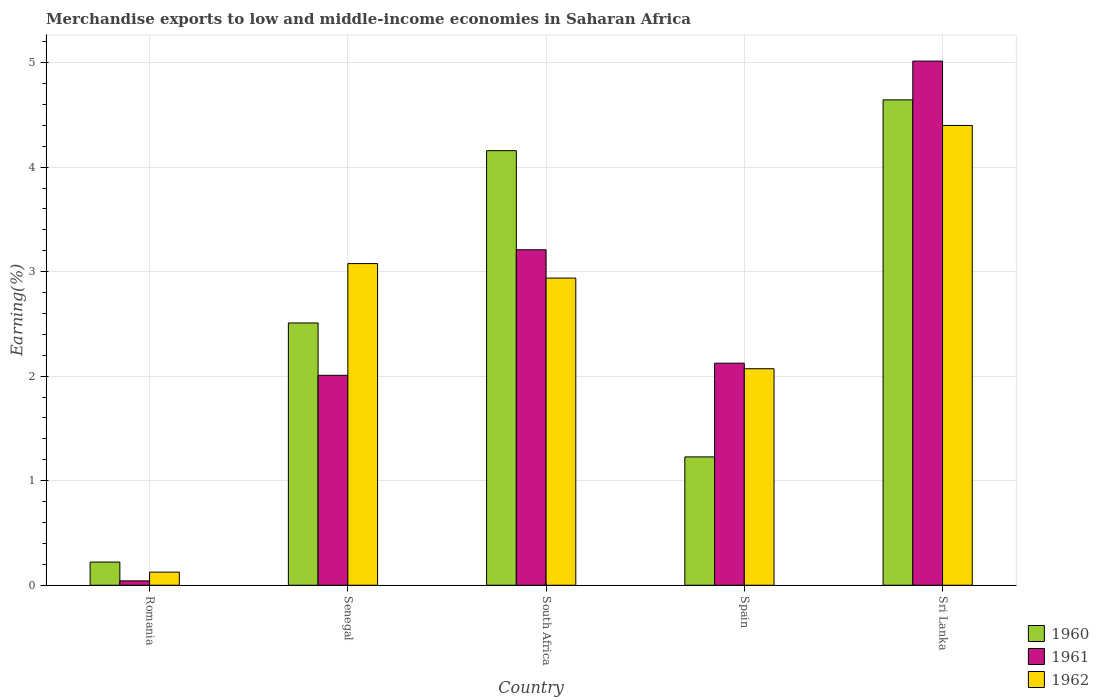How many different coloured bars are there?
Offer a terse response. 3. How many groups of bars are there?
Offer a very short reply. 5. Are the number of bars per tick equal to the number of legend labels?
Ensure brevity in your answer.  Yes. How many bars are there on the 1st tick from the left?
Ensure brevity in your answer.  3. What is the label of the 2nd group of bars from the left?
Your answer should be very brief. Senegal. What is the percentage of amount earned from merchandise exports in 1961 in Sri Lanka?
Offer a very short reply. 5.01. Across all countries, what is the maximum percentage of amount earned from merchandise exports in 1962?
Keep it short and to the point. 4.4. Across all countries, what is the minimum percentage of amount earned from merchandise exports in 1960?
Provide a succinct answer. 0.22. In which country was the percentage of amount earned from merchandise exports in 1960 maximum?
Your answer should be compact. Sri Lanka. In which country was the percentage of amount earned from merchandise exports in 1962 minimum?
Your response must be concise. Romania. What is the total percentage of amount earned from merchandise exports in 1962 in the graph?
Provide a succinct answer. 12.61. What is the difference between the percentage of amount earned from merchandise exports in 1960 in Spain and that in Sri Lanka?
Ensure brevity in your answer.  -3.42. What is the difference between the percentage of amount earned from merchandise exports in 1962 in Sri Lanka and the percentage of amount earned from merchandise exports in 1961 in South Africa?
Your answer should be very brief. 1.19. What is the average percentage of amount earned from merchandise exports in 1962 per country?
Offer a terse response. 2.52. What is the difference between the percentage of amount earned from merchandise exports of/in 1962 and percentage of amount earned from merchandise exports of/in 1960 in South Africa?
Your answer should be compact. -1.22. In how many countries, is the percentage of amount earned from merchandise exports in 1961 greater than 1 %?
Make the answer very short. 4. What is the ratio of the percentage of amount earned from merchandise exports in 1962 in Spain to that in Sri Lanka?
Provide a succinct answer. 0.47. Is the percentage of amount earned from merchandise exports in 1961 in Romania less than that in Spain?
Provide a succinct answer. Yes. Is the difference between the percentage of amount earned from merchandise exports in 1962 in Romania and Senegal greater than the difference between the percentage of amount earned from merchandise exports in 1960 in Romania and Senegal?
Your answer should be very brief. No. What is the difference between the highest and the second highest percentage of amount earned from merchandise exports in 1961?
Your response must be concise. -1.09. What is the difference between the highest and the lowest percentage of amount earned from merchandise exports in 1961?
Give a very brief answer. 4.97. Is the sum of the percentage of amount earned from merchandise exports in 1960 in Romania and South Africa greater than the maximum percentage of amount earned from merchandise exports in 1961 across all countries?
Provide a succinct answer. No. How many bars are there?
Give a very brief answer. 15. Are all the bars in the graph horizontal?
Your answer should be very brief. No. How many countries are there in the graph?
Give a very brief answer. 5. What is the difference between two consecutive major ticks on the Y-axis?
Offer a terse response. 1. Are the values on the major ticks of Y-axis written in scientific E-notation?
Ensure brevity in your answer.  No. Does the graph contain grids?
Provide a succinct answer. Yes. What is the title of the graph?
Your answer should be compact. Merchandise exports to low and middle-income economies in Saharan Africa. What is the label or title of the Y-axis?
Provide a short and direct response. Earning(%). What is the Earning(%) of 1960 in Romania?
Make the answer very short. 0.22. What is the Earning(%) of 1961 in Romania?
Your answer should be very brief. 0.04. What is the Earning(%) in 1962 in Romania?
Keep it short and to the point. 0.13. What is the Earning(%) in 1960 in Senegal?
Offer a very short reply. 2.51. What is the Earning(%) of 1961 in Senegal?
Keep it short and to the point. 2.01. What is the Earning(%) in 1962 in Senegal?
Offer a terse response. 3.08. What is the Earning(%) in 1960 in South Africa?
Offer a terse response. 4.16. What is the Earning(%) in 1961 in South Africa?
Your answer should be compact. 3.21. What is the Earning(%) in 1962 in South Africa?
Ensure brevity in your answer.  2.94. What is the Earning(%) of 1960 in Spain?
Give a very brief answer. 1.23. What is the Earning(%) in 1961 in Spain?
Provide a succinct answer. 2.12. What is the Earning(%) of 1962 in Spain?
Offer a very short reply. 2.07. What is the Earning(%) of 1960 in Sri Lanka?
Your answer should be very brief. 4.64. What is the Earning(%) in 1961 in Sri Lanka?
Offer a terse response. 5.01. What is the Earning(%) in 1962 in Sri Lanka?
Your answer should be compact. 4.4. Across all countries, what is the maximum Earning(%) of 1960?
Provide a short and direct response. 4.64. Across all countries, what is the maximum Earning(%) in 1961?
Provide a short and direct response. 5.01. Across all countries, what is the maximum Earning(%) of 1962?
Your answer should be compact. 4.4. Across all countries, what is the minimum Earning(%) in 1960?
Your response must be concise. 0.22. Across all countries, what is the minimum Earning(%) of 1961?
Give a very brief answer. 0.04. Across all countries, what is the minimum Earning(%) of 1962?
Your answer should be very brief. 0.13. What is the total Earning(%) of 1960 in the graph?
Ensure brevity in your answer.  12.76. What is the total Earning(%) in 1961 in the graph?
Offer a terse response. 12.4. What is the total Earning(%) of 1962 in the graph?
Offer a terse response. 12.61. What is the difference between the Earning(%) of 1960 in Romania and that in Senegal?
Your answer should be very brief. -2.29. What is the difference between the Earning(%) of 1961 in Romania and that in Senegal?
Keep it short and to the point. -1.97. What is the difference between the Earning(%) of 1962 in Romania and that in Senegal?
Offer a very short reply. -2.95. What is the difference between the Earning(%) in 1960 in Romania and that in South Africa?
Provide a short and direct response. -3.94. What is the difference between the Earning(%) of 1961 in Romania and that in South Africa?
Provide a short and direct response. -3.17. What is the difference between the Earning(%) of 1962 in Romania and that in South Africa?
Make the answer very short. -2.81. What is the difference between the Earning(%) of 1960 in Romania and that in Spain?
Your answer should be very brief. -1.01. What is the difference between the Earning(%) of 1961 in Romania and that in Spain?
Keep it short and to the point. -2.08. What is the difference between the Earning(%) of 1962 in Romania and that in Spain?
Provide a short and direct response. -1.95. What is the difference between the Earning(%) in 1960 in Romania and that in Sri Lanka?
Your answer should be compact. -4.42. What is the difference between the Earning(%) in 1961 in Romania and that in Sri Lanka?
Provide a short and direct response. -4.97. What is the difference between the Earning(%) in 1962 in Romania and that in Sri Lanka?
Your answer should be compact. -4.27. What is the difference between the Earning(%) of 1960 in Senegal and that in South Africa?
Give a very brief answer. -1.65. What is the difference between the Earning(%) of 1961 in Senegal and that in South Africa?
Offer a terse response. -1.2. What is the difference between the Earning(%) in 1962 in Senegal and that in South Africa?
Give a very brief answer. 0.14. What is the difference between the Earning(%) in 1960 in Senegal and that in Spain?
Provide a succinct answer. 1.28. What is the difference between the Earning(%) in 1961 in Senegal and that in Spain?
Your response must be concise. -0.12. What is the difference between the Earning(%) in 1960 in Senegal and that in Sri Lanka?
Your response must be concise. -2.13. What is the difference between the Earning(%) of 1961 in Senegal and that in Sri Lanka?
Your response must be concise. -3.01. What is the difference between the Earning(%) of 1962 in Senegal and that in Sri Lanka?
Give a very brief answer. -1.32. What is the difference between the Earning(%) of 1960 in South Africa and that in Spain?
Ensure brevity in your answer.  2.93. What is the difference between the Earning(%) of 1961 in South Africa and that in Spain?
Your answer should be compact. 1.09. What is the difference between the Earning(%) of 1962 in South Africa and that in Spain?
Your response must be concise. 0.87. What is the difference between the Earning(%) of 1960 in South Africa and that in Sri Lanka?
Ensure brevity in your answer.  -0.49. What is the difference between the Earning(%) in 1961 in South Africa and that in Sri Lanka?
Keep it short and to the point. -1.8. What is the difference between the Earning(%) of 1962 in South Africa and that in Sri Lanka?
Your answer should be very brief. -1.46. What is the difference between the Earning(%) of 1960 in Spain and that in Sri Lanka?
Provide a short and direct response. -3.42. What is the difference between the Earning(%) in 1961 in Spain and that in Sri Lanka?
Your answer should be very brief. -2.89. What is the difference between the Earning(%) of 1962 in Spain and that in Sri Lanka?
Keep it short and to the point. -2.33. What is the difference between the Earning(%) of 1960 in Romania and the Earning(%) of 1961 in Senegal?
Provide a short and direct response. -1.79. What is the difference between the Earning(%) in 1960 in Romania and the Earning(%) in 1962 in Senegal?
Ensure brevity in your answer.  -2.86. What is the difference between the Earning(%) in 1961 in Romania and the Earning(%) in 1962 in Senegal?
Your answer should be compact. -3.04. What is the difference between the Earning(%) in 1960 in Romania and the Earning(%) in 1961 in South Africa?
Offer a very short reply. -2.99. What is the difference between the Earning(%) of 1960 in Romania and the Earning(%) of 1962 in South Africa?
Provide a short and direct response. -2.72. What is the difference between the Earning(%) of 1961 in Romania and the Earning(%) of 1962 in South Africa?
Provide a short and direct response. -2.9. What is the difference between the Earning(%) in 1960 in Romania and the Earning(%) in 1961 in Spain?
Give a very brief answer. -1.9. What is the difference between the Earning(%) of 1960 in Romania and the Earning(%) of 1962 in Spain?
Offer a very short reply. -1.85. What is the difference between the Earning(%) in 1961 in Romania and the Earning(%) in 1962 in Spain?
Provide a succinct answer. -2.03. What is the difference between the Earning(%) in 1960 in Romania and the Earning(%) in 1961 in Sri Lanka?
Your answer should be very brief. -4.79. What is the difference between the Earning(%) in 1960 in Romania and the Earning(%) in 1962 in Sri Lanka?
Offer a very short reply. -4.18. What is the difference between the Earning(%) of 1961 in Romania and the Earning(%) of 1962 in Sri Lanka?
Your answer should be very brief. -4.36. What is the difference between the Earning(%) in 1960 in Senegal and the Earning(%) in 1961 in South Africa?
Ensure brevity in your answer.  -0.7. What is the difference between the Earning(%) in 1960 in Senegal and the Earning(%) in 1962 in South Africa?
Make the answer very short. -0.43. What is the difference between the Earning(%) of 1961 in Senegal and the Earning(%) of 1962 in South Africa?
Your answer should be compact. -0.93. What is the difference between the Earning(%) in 1960 in Senegal and the Earning(%) in 1961 in Spain?
Give a very brief answer. 0.38. What is the difference between the Earning(%) of 1960 in Senegal and the Earning(%) of 1962 in Spain?
Your answer should be compact. 0.44. What is the difference between the Earning(%) of 1961 in Senegal and the Earning(%) of 1962 in Spain?
Offer a terse response. -0.06. What is the difference between the Earning(%) of 1960 in Senegal and the Earning(%) of 1961 in Sri Lanka?
Ensure brevity in your answer.  -2.51. What is the difference between the Earning(%) of 1960 in Senegal and the Earning(%) of 1962 in Sri Lanka?
Your answer should be compact. -1.89. What is the difference between the Earning(%) of 1961 in Senegal and the Earning(%) of 1962 in Sri Lanka?
Give a very brief answer. -2.39. What is the difference between the Earning(%) of 1960 in South Africa and the Earning(%) of 1961 in Spain?
Give a very brief answer. 2.03. What is the difference between the Earning(%) of 1960 in South Africa and the Earning(%) of 1962 in Spain?
Your answer should be compact. 2.09. What is the difference between the Earning(%) of 1961 in South Africa and the Earning(%) of 1962 in Spain?
Your response must be concise. 1.14. What is the difference between the Earning(%) in 1960 in South Africa and the Earning(%) in 1961 in Sri Lanka?
Your response must be concise. -0.86. What is the difference between the Earning(%) in 1960 in South Africa and the Earning(%) in 1962 in Sri Lanka?
Provide a short and direct response. -0.24. What is the difference between the Earning(%) of 1961 in South Africa and the Earning(%) of 1962 in Sri Lanka?
Ensure brevity in your answer.  -1.19. What is the difference between the Earning(%) of 1960 in Spain and the Earning(%) of 1961 in Sri Lanka?
Offer a terse response. -3.79. What is the difference between the Earning(%) in 1960 in Spain and the Earning(%) in 1962 in Sri Lanka?
Ensure brevity in your answer.  -3.17. What is the difference between the Earning(%) in 1961 in Spain and the Earning(%) in 1962 in Sri Lanka?
Your answer should be compact. -2.27. What is the average Earning(%) of 1960 per country?
Your answer should be compact. 2.55. What is the average Earning(%) in 1961 per country?
Offer a very short reply. 2.48. What is the average Earning(%) in 1962 per country?
Make the answer very short. 2.52. What is the difference between the Earning(%) of 1960 and Earning(%) of 1961 in Romania?
Provide a succinct answer. 0.18. What is the difference between the Earning(%) of 1960 and Earning(%) of 1962 in Romania?
Offer a terse response. 0.1. What is the difference between the Earning(%) in 1961 and Earning(%) in 1962 in Romania?
Give a very brief answer. -0.08. What is the difference between the Earning(%) in 1960 and Earning(%) in 1961 in Senegal?
Your response must be concise. 0.5. What is the difference between the Earning(%) in 1960 and Earning(%) in 1962 in Senegal?
Offer a very short reply. -0.57. What is the difference between the Earning(%) in 1961 and Earning(%) in 1962 in Senegal?
Give a very brief answer. -1.07. What is the difference between the Earning(%) of 1960 and Earning(%) of 1961 in South Africa?
Make the answer very short. 0.95. What is the difference between the Earning(%) in 1960 and Earning(%) in 1962 in South Africa?
Provide a short and direct response. 1.22. What is the difference between the Earning(%) in 1961 and Earning(%) in 1962 in South Africa?
Keep it short and to the point. 0.27. What is the difference between the Earning(%) in 1960 and Earning(%) in 1961 in Spain?
Provide a short and direct response. -0.9. What is the difference between the Earning(%) in 1960 and Earning(%) in 1962 in Spain?
Provide a succinct answer. -0.84. What is the difference between the Earning(%) in 1961 and Earning(%) in 1962 in Spain?
Make the answer very short. 0.05. What is the difference between the Earning(%) of 1960 and Earning(%) of 1961 in Sri Lanka?
Your answer should be compact. -0.37. What is the difference between the Earning(%) of 1960 and Earning(%) of 1962 in Sri Lanka?
Provide a succinct answer. 0.24. What is the difference between the Earning(%) of 1961 and Earning(%) of 1962 in Sri Lanka?
Give a very brief answer. 0.62. What is the ratio of the Earning(%) in 1960 in Romania to that in Senegal?
Provide a succinct answer. 0.09. What is the ratio of the Earning(%) in 1961 in Romania to that in Senegal?
Give a very brief answer. 0.02. What is the ratio of the Earning(%) of 1962 in Romania to that in Senegal?
Keep it short and to the point. 0.04. What is the ratio of the Earning(%) of 1960 in Romania to that in South Africa?
Provide a succinct answer. 0.05. What is the ratio of the Earning(%) of 1961 in Romania to that in South Africa?
Offer a very short reply. 0.01. What is the ratio of the Earning(%) in 1962 in Romania to that in South Africa?
Provide a short and direct response. 0.04. What is the ratio of the Earning(%) of 1960 in Romania to that in Spain?
Provide a succinct answer. 0.18. What is the ratio of the Earning(%) in 1961 in Romania to that in Spain?
Offer a terse response. 0.02. What is the ratio of the Earning(%) in 1962 in Romania to that in Spain?
Keep it short and to the point. 0.06. What is the ratio of the Earning(%) of 1960 in Romania to that in Sri Lanka?
Your response must be concise. 0.05. What is the ratio of the Earning(%) of 1961 in Romania to that in Sri Lanka?
Ensure brevity in your answer.  0.01. What is the ratio of the Earning(%) in 1962 in Romania to that in Sri Lanka?
Your answer should be very brief. 0.03. What is the ratio of the Earning(%) of 1960 in Senegal to that in South Africa?
Give a very brief answer. 0.6. What is the ratio of the Earning(%) of 1961 in Senegal to that in South Africa?
Make the answer very short. 0.63. What is the ratio of the Earning(%) in 1962 in Senegal to that in South Africa?
Keep it short and to the point. 1.05. What is the ratio of the Earning(%) of 1960 in Senegal to that in Spain?
Offer a very short reply. 2.04. What is the ratio of the Earning(%) of 1961 in Senegal to that in Spain?
Give a very brief answer. 0.95. What is the ratio of the Earning(%) of 1962 in Senegal to that in Spain?
Your response must be concise. 1.49. What is the ratio of the Earning(%) in 1960 in Senegal to that in Sri Lanka?
Your answer should be compact. 0.54. What is the ratio of the Earning(%) in 1961 in Senegal to that in Sri Lanka?
Your response must be concise. 0.4. What is the ratio of the Earning(%) of 1962 in Senegal to that in Sri Lanka?
Make the answer very short. 0.7. What is the ratio of the Earning(%) in 1960 in South Africa to that in Spain?
Your answer should be compact. 3.39. What is the ratio of the Earning(%) of 1961 in South Africa to that in Spain?
Offer a very short reply. 1.51. What is the ratio of the Earning(%) in 1962 in South Africa to that in Spain?
Provide a short and direct response. 1.42. What is the ratio of the Earning(%) in 1960 in South Africa to that in Sri Lanka?
Provide a succinct answer. 0.9. What is the ratio of the Earning(%) of 1961 in South Africa to that in Sri Lanka?
Your response must be concise. 0.64. What is the ratio of the Earning(%) of 1962 in South Africa to that in Sri Lanka?
Provide a short and direct response. 0.67. What is the ratio of the Earning(%) in 1960 in Spain to that in Sri Lanka?
Provide a succinct answer. 0.26. What is the ratio of the Earning(%) in 1961 in Spain to that in Sri Lanka?
Provide a short and direct response. 0.42. What is the ratio of the Earning(%) in 1962 in Spain to that in Sri Lanka?
Provide a succinct answer. 0.47. What is the difference between the highest and the second highest Earning(%) in 1960?
Your response must be concise. 0.49. What is the difference between the highest and the second highest Earning(%) of 1961?
Provide a short and direct response. 1.8. What is the difference between the highest and the second highest Earning(%) in 1962?
Give a very brief answer. 1.32. What is the difference between the highest and the lowest Earning(%) of 1960?
Give a very brief answer. 4.42. What is the difference between the highest and the lowest Earning(%) of 1961?
Offer a very short reply. 4.97. What is the difference between the highest and the lowest Earning(%) in 1962?
Provide a short and direct response. 4.27. 